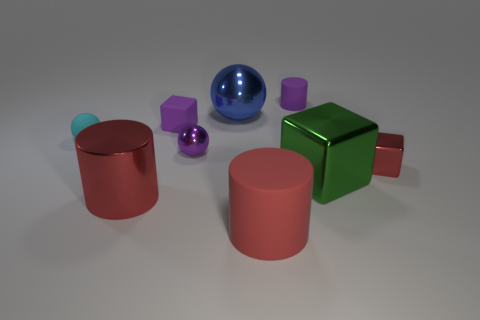Subtract all spheres. How many objects are left? 6 Subtract all big blue cylinders. Subtract all blue things. How many objects are left? 8 Add 5 tiny purple metallic objects. How many tiny purple metallic objects are left? 6 Add 5 tiny brown things. How many tiny brown things exist? 5 Subtract 0 brown balls. How many objects are left? 9 